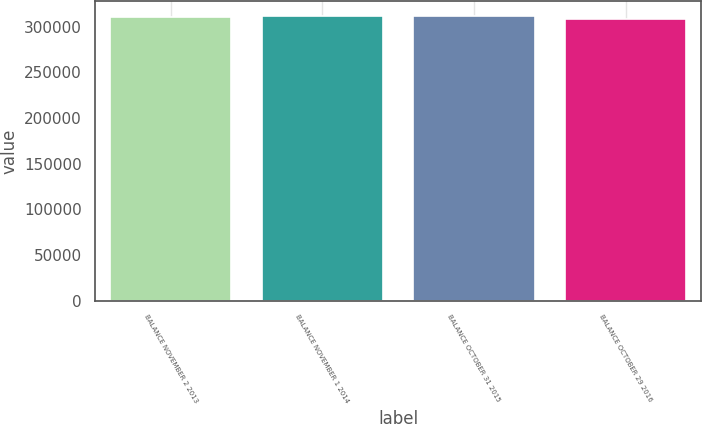Convert chart to OTSL. <chart><loc_0><loc_0><loc_500><loc_500><bar_chart><fcel>BALANCE NOVEMBER 2 2013<fcel>BALANCE NOVEMBER 1 2014<fcel>BALANCE OCTOBER 31 2015<fcel>BALANCE OCTOBER 29 2016<nl><fcel>311045<fcel>311434<fcel>312061<fcel>308171<nl></chart> 